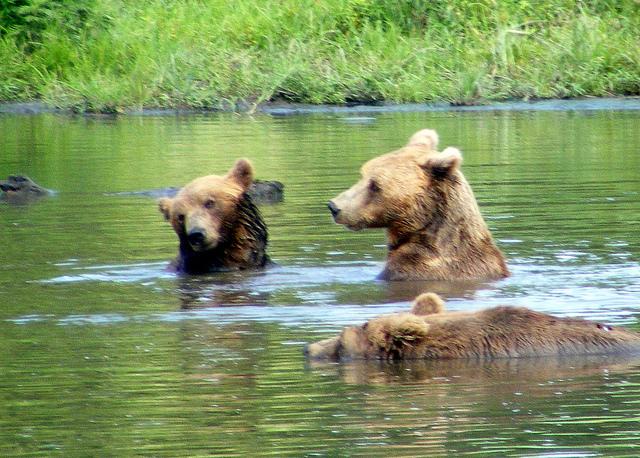What are the bears doing?
Write a very short answer. Swimming. Are the bears on land?
Give a very brief answer. No. How many bears are in this picture?
Concise answer only. 3. 